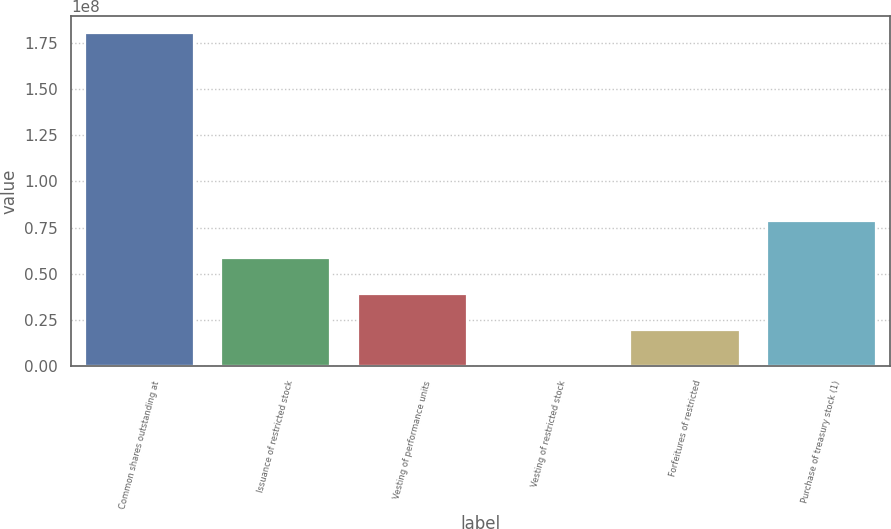Convert chart to OTSL. <chart><loc_0><loc_0><loc_500><loc_500><bar_chart><fcel>Common shares outstanding at<fcel>Issuance of restricted stock<fcel>Vesting of performance units<fcel>Vesting of restricted stock<fcel>Forfeitures of restricted<fcel>Purchase of treasury stock (1)<nl><fcel>1.80234e+08<fcel>5.88565e+07<fcel>3.92522e+07<fcel>43774<fcel>1.9648e+07<fcel>7.84607e+07<nl></chart> 